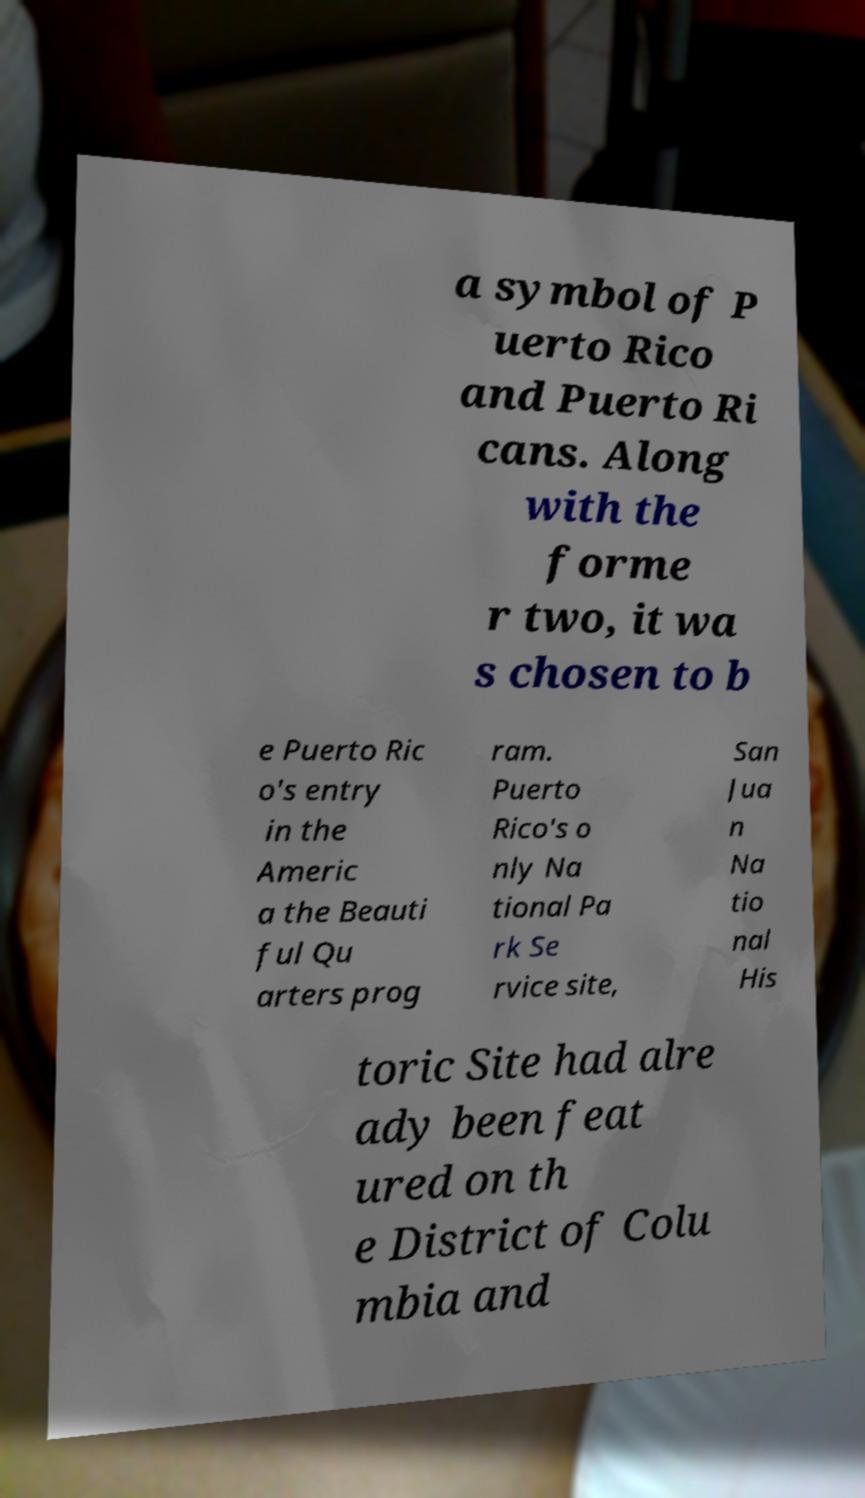For documentation purposes, I need the text within this image transcribed. Could you provide that? a symbol of P uerto Rico and Puerto Ri cans. Along with the forme r two, it wa s chosen to b e Puerto Ric o's entry in the Americ a the Beauti ful Qu arters prog ram. Puerto Rico's o nly Na tional Pa rk Se rvice site, San Jua n Na tio nal His toric Site had alre ady been feat ured on th e District of Colu mbia and 